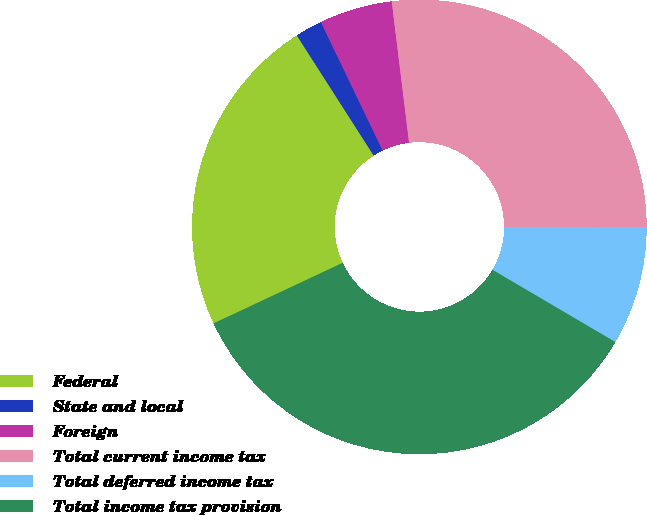Convert chart. <chart><loc_0><loc_0><loc_500><loc_500><pie_chart><fcel>Federal<fcel>State and local<fcel>Foreign<fcel>Total current income tax<fcel>Total deferred income tax<fcel>Total income tax provision<nl><fcel>22.92%<fcel>1.93%<fcel>5.19%<fcel>26.95%<fcel>8.45%<fcel>34.56%<nl></chart> 